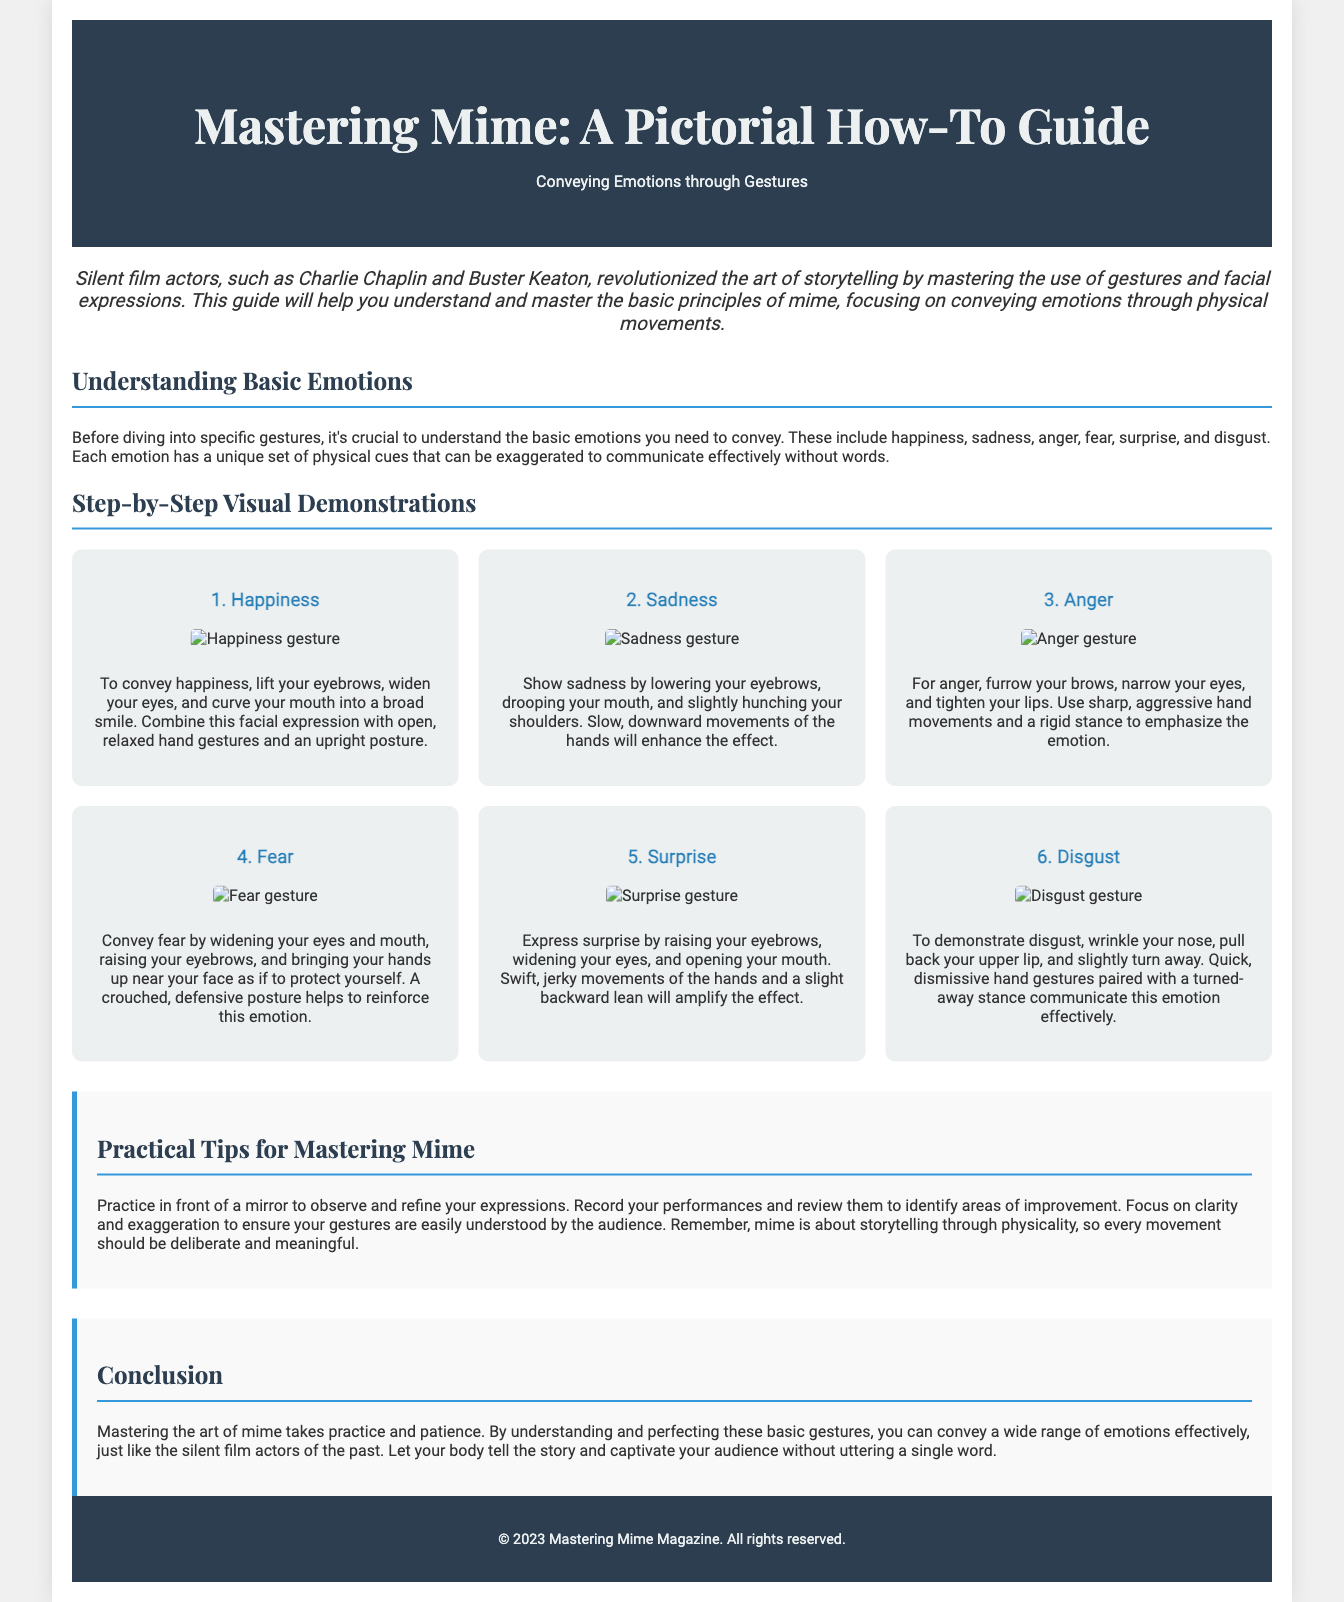What is the title of the guide? The title of the guide is explicitly stated at the top of the document.
Answer: Mastering Mime: A Pictorial How-To Guide Who are two examples of silent film actors mentioned in the introduction? The introduction highlights notable silent film actors as examples of those who excelled in mime.
Answer: Charlie Chaplin and Buster Keaton What are the six basic emotions discussed in the guide? The document lists the six basic emotions that the guide focuses on conveying through gestures.
Answer: Happiness, Sadness, Anger, Fear, Surprise, Disgust Which emotion is associated with drooping shoulders? This question pertains to the physical cues described for sadness in the document.
Answer: Sadness How can one express surprise according to the guide? The guide specifies the facial expressions and movements associated with surprise.
Answer: Raising eyebrows and widening eyes What is one practical tip for mastering mime mentioned in the guide? The tips section provides suggestions for improving mime skills through practice.
Answer: Practice in front of a mirror What should every movement in mime be described as? The conclusion summarizes how movements should be approached in the practice of mime.
Answer: Deliberate and meaningful 